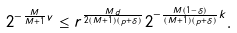Convert formula to latex. <formula><loc_0><loc_0><loc_500><loc_500>2 ^ { - \frac { M } { M + 1 } v } \leq r ^ { \frac { M d } { 2 ( M + 1 ) ( p + \delta ) } } 2 ^ { - \frac { M ( 1 - \delta ) } { ( M + 1 ) ( p + \delta ) } k } .</formula> 